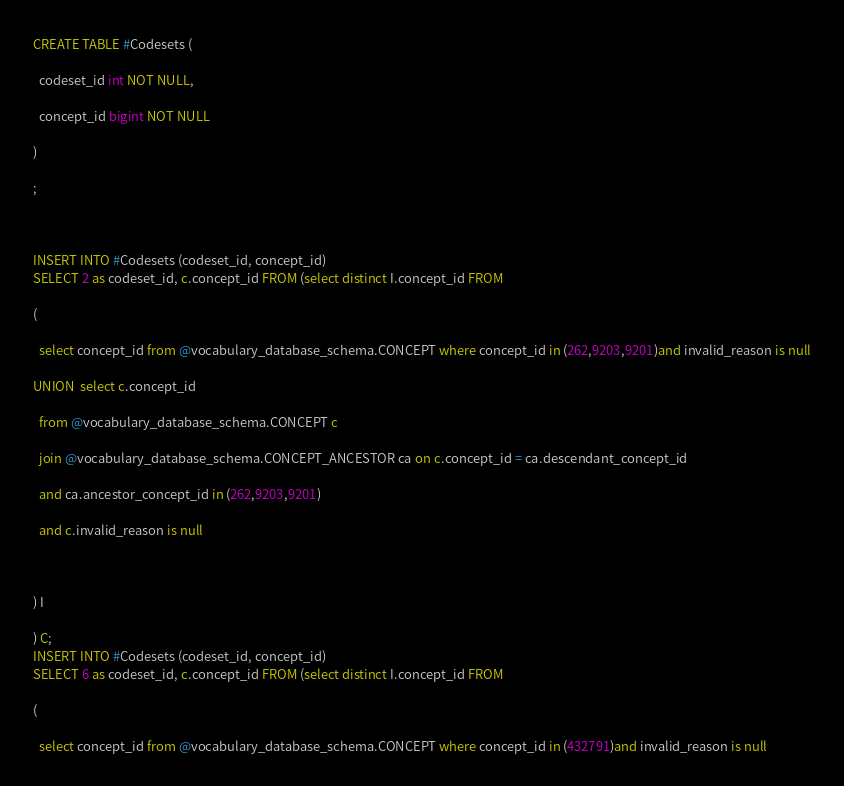<code> <loc_0><loc_0><loc_500><loc_500><_SQL_>CREATE TABLE #Codesets (
  codeset_id int NOT NULL,
  concept_id bigint NOT NULL
)
;

INSERT INTO #Codesets (codeset_id, concept_id)
SELECT 2 as codeset_id, c.concept_id FROM (select distinct I.concept_id FROM
( 
  select concept_id from @vocabulary_database_schema.CONCEPT where concept_id in (262,9203,9201)and invalid_reason is null
UNION  select c.concept_id
  from @vocabulary_database_schema.CONCEPT c
  join @vocabulary_database_schema.CONCEPT_ANCESTOR ca on c.concept_id = ca.descendant_concept_id
  and ca.ancestor_concept_id in (262,9203,9201)
  and c.invalid_reason is null

) I
) C;
INSERT INTO #Codesets (codeset_id, concept_id)
SELECT 6 as codeset_id, c.concept_id FROM (select distinct I.concept_id FROM
( 
  select concept_id from @vocabulary_database_schema.CONCEPT where concept_id in (432791)and invalid_reason is null</code> 